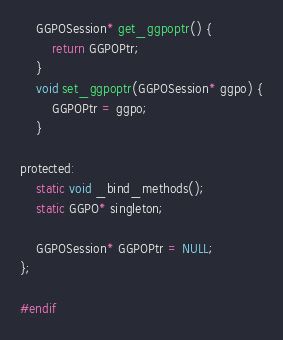Convert code to text. <code><loc_0><loc_0><loc_500><loc_500><_C_>
    GGPOSession* get_ggpoptr() {
        return GGPOPtr;
    }
    void set_ggpoptr(GGPOSession* ggpo) {
        GGPOPtr = ggpo;
    }

protected:
    static void _bind_methods();
    static GGPO* singleton;

    GGPOSession* GGPOPtr = NULL;
};

#endif</code> 